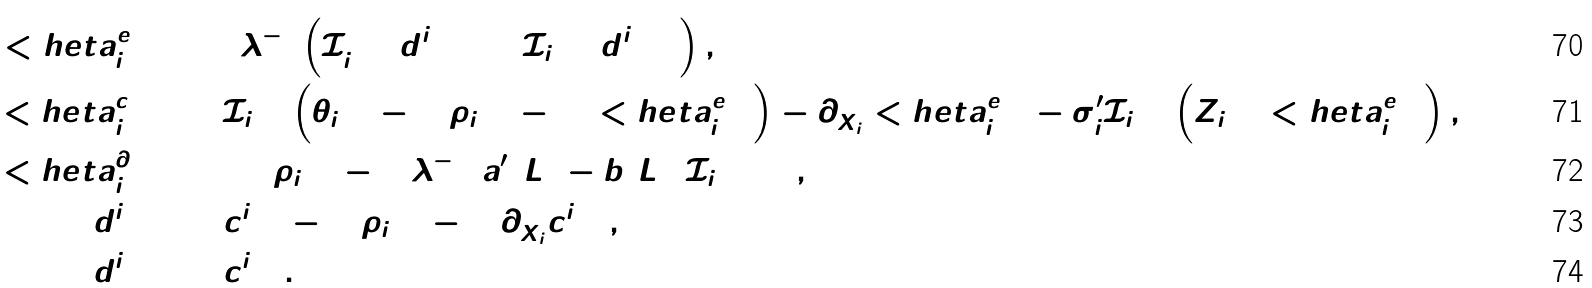Convert formula to latex. <formula><loc_0><loc_0><loc_500><loc_500>< h e t a ^ { e } _ { i + 1 } \colon = & 2 \lambda ^ { - 1 } \left ( { \mathcal { I } } _ { i + 1 } ^ { 2 } ( d _ { 2 } ^ { i + 1 } ) + { \mathcal { I } } _ { i + 1 } ( d ^ { i + 1 } _ { 1 } ) \right ) , \\ { < h e t a } _ { i + 1 } ^ { c } \colon = & { { \mathcal { I } } } _ { i + 1 } \left ( \bar { \theta } _ { i + 1 } - ( 2 \rho _ { i + 1 } - 1 ) < h e t a ^ { e } _ { i + 1 } \right ) - \partial _ { \bar { X } _ { i } } < h e t a ^ { e } _ { i + 1 } - \sigma ^ { \prime } _ { i } { { \mathcal { I } } } _ { i + 1 } \left ( Z _ { i + 1 } < h e t a ^ { e } _ { i + 1 } \right ) , \\ { < h e t a } _ { i + 1 } ^ { \partial } \colon = & 2 ( 2 \rho _ { i + 1 } - 1 ) \lambda ^ { - 1 } ( a ^ { \prime } ( L ) - b ( L ) ) { \mathcal { I } } _ { i + 1 } ( 1 ) , \\ d _ { 1 } ^ { i + 1 } \colon = & c _ { 1 } ^ { i + 1 } - ( 2 \rho _ { i + 1 } - 1 ) \partial _ { \bar { X } _ { i } } c _ { 2 } ^ { i + 1 } , \\ d _ { 2 } ^ { i + 1 } \colon = & c _ { 2 } ^ { i + 1 } .</formula> 